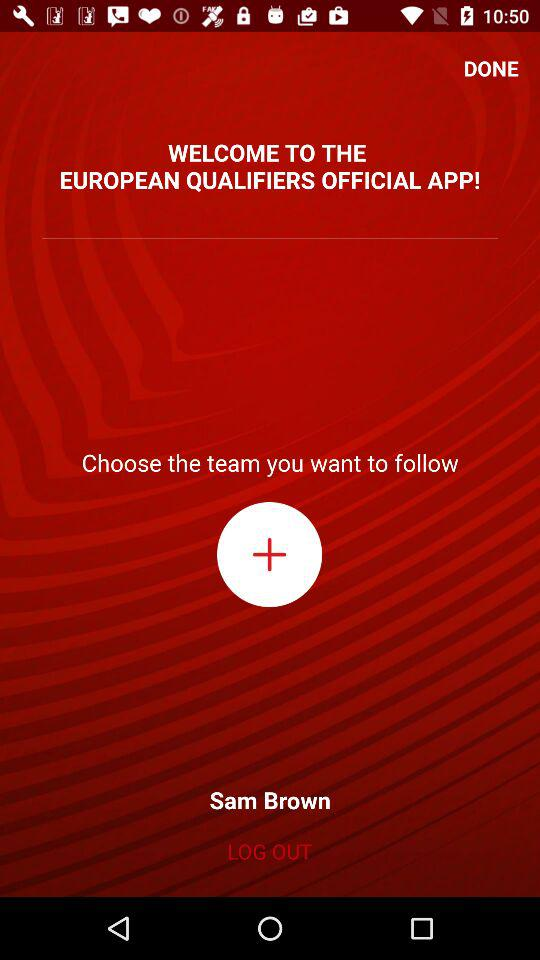What is the name of the user? The name of the user is Sam Brown. 